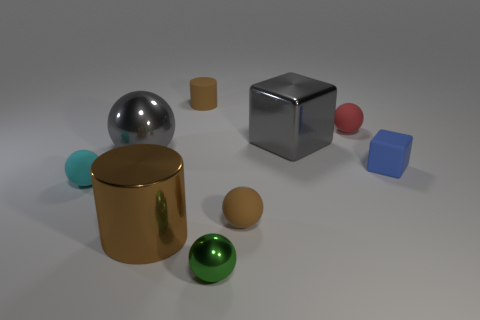Subtract all gray spheres. How many spheres are left? 4 Subtract all tiny green balls. How many balls are left? 4 Subtract 1 balls. How many balls are left? 4 Subtract all blue spheres. Subtract all green blocks. How many spheres are left? 5 Add 1 small red rubber cylinders. How many objects exist? 10 Subtract all balls. How many objects are left? 4 Subtract 0 purple balls. How many objects are left? 9 Subtract all brown spheres. Subtract all large blue metal objects. How many objects are left? 8 Add 1 brown things. How many brown things are left? 4 Add 1 large gray metallic spheres. How many large gray metallic spheres exist? 2 